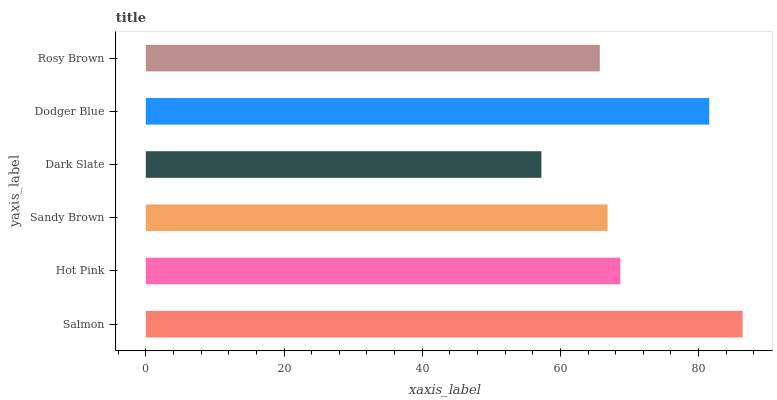Is Dark Slate the minimum?
Answer yes or no. Yes. Is Salmon the maximum?
Answer yes or no. Yes. Is Hot Pink the minimum?
Answer yes or no. No. Is Hot Pink the maximum?
Answer yes or no. No. Is Salmon greater than Hot Pink?
Answer yes or no. Yes. Is Hot Pink less than Salmon?
Answer yes or no. Yes. Is Hot Pink greater than Salmon?
Answer yes or no. No. Is Salmon less than Hot Pink?
Answer yes or no. No. Is Hot Pink the high median?
Answer yes or no. Yes. Is Sandy Brown the low median?
Answer yes or no. Yes. Is Dodger Blue the high median?
Answer yes or no. No. Is Hot Pink the low median?
Answer yes or no. No. 